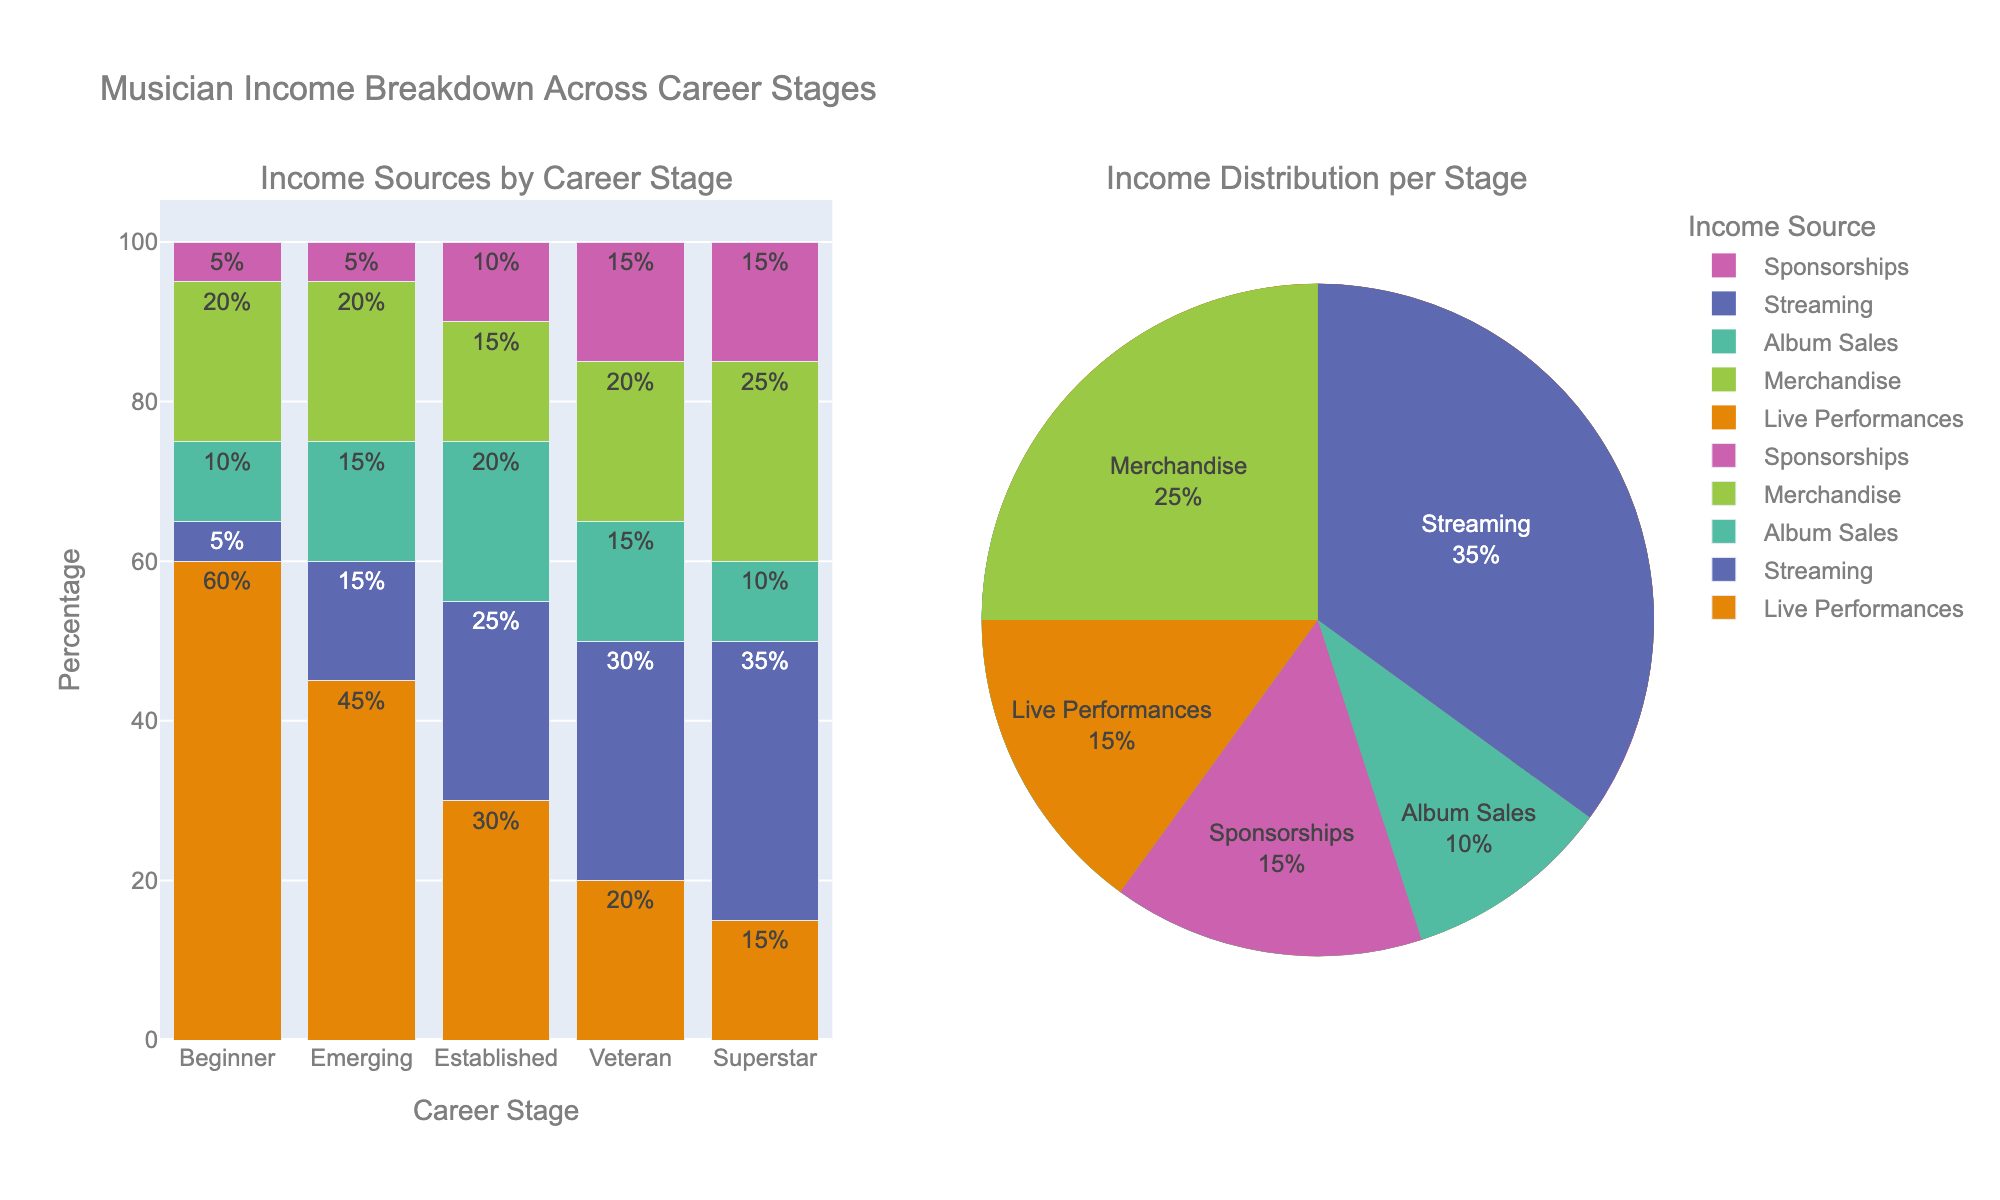What is the title of the figure? The title is located at the top and it summarizes the main topic of the figure.
Answer: Musician Income Breakdown Across Career Stages Which career stage has the highest percentage of income coming from Live Performances? From the bar chart, observe the height of the Live Performances segment which is colored distinctly. The Beginner stage has the tallest segment for Live Performances.
Answer: Beginner What is the combined percentage of income from Album Sales and Streaming for the Established career stage? Add the percentages of Album Sales and Streaming shown for the Established stage on the bar chart. Album Sales is 20% and Streaming is 25%, so the combined is 20 + 25.
Answer: 45% Which income source sees the highest increase in percentage from the Beginner to the Superstar stage? Compare the heights of each segment (income source) from Beginner to Superstar. Streaming grows from 5% to 35%, which is the highest increase of 30%.
Answer: Streaming How does the income distribution for the Veteran stage differ from the Emerging stage for Merchandise and Sponsorships? Look at the heights of the Merchandise and Sponsorship segments in the bar chart for both stages. Veterans have 20% Merchandise and 15% Sponsorships, while Emerging has 20% Merchandise and 5% Sponsorships. So Sponsorships increase from Emerging to Veteran by 10%.
Answer: Sponsorships for Veteran increase by 10% compared to Emerging What percentage of income for Superstars is derived from Merchandise? Reference the bar chart and look for the Merchandise segment for the Superstar stage. It is colored, and its height represents 25%.
Answer: 25% In which career stage does Streaming contribute more to the income than Live Performances? Compare the Streaming and Live Performances segments across all stages. From the bar chart, both Veteran and Superstar have higher percentages for Streaming than Live Performances.
Answer: Veteran and Superstar Compute the average percentage of income from Album Sales across all career stages. Sum the Album Sales percentages for all career stages and divide by the number of stages. (10+15+20+15+10)/5 = 14%.
Answer: 14% What is the difference in the percentage of income from Album Sales between the Emerging and the Established stages? Look at the Album Sales percentages for both stages from the bar chart. Emerging has 15% and Established has 20%, the difference is 20 - 15.
Answer: 5% Which income source generally shows an increasing trend as musicians advance in their career stages? Observe the bar chart; Streaming increases as you go from Beginner to Superstar (5% to 35%).
Answer: Streaming 